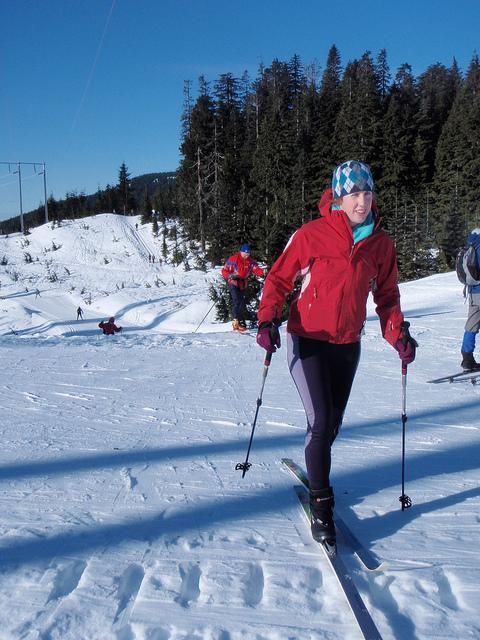Is  the woman wearing tight fitting pants?
Give a very brief answer. Yes. What is the skier holding in her hands?
Keep it brief. Poles. Is it hot in the picture?
Be succinct. No. Is the snow deep?
Be succinct. Yes. 